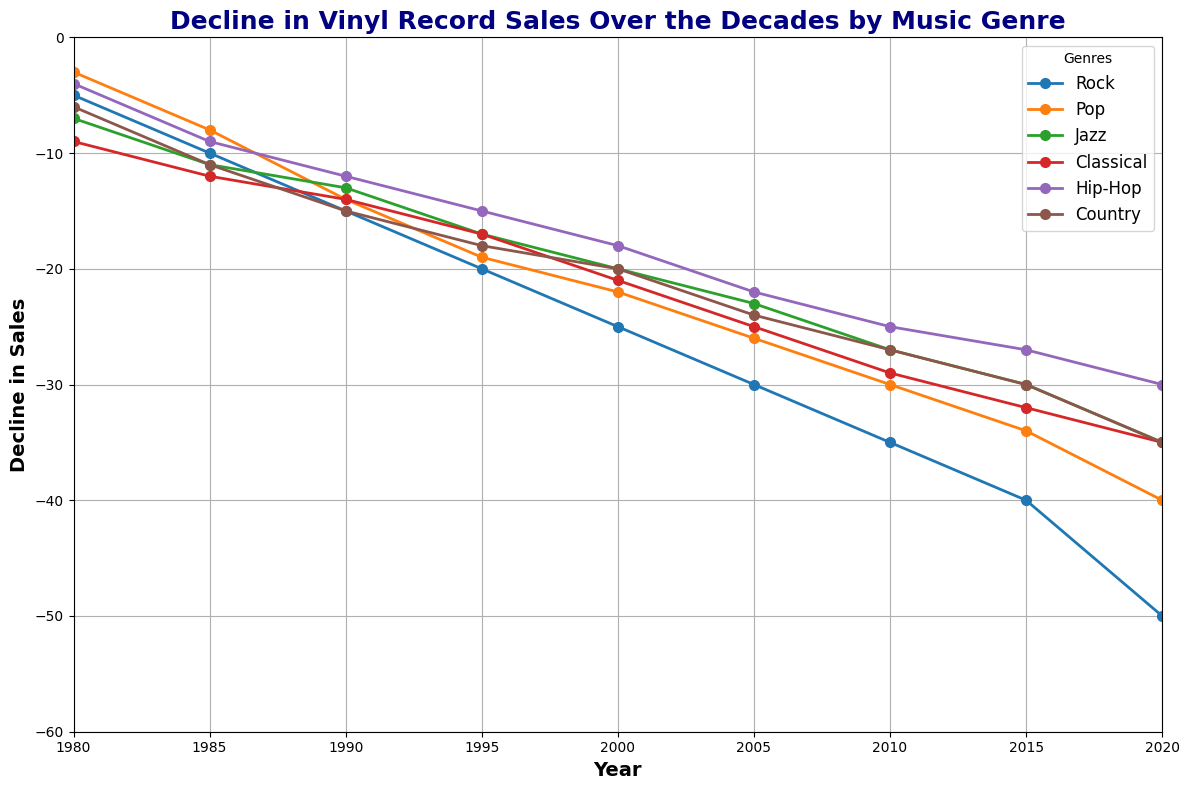What genre experienced the steepest decline in sales from 1985 to 1990? To determine the steepest decline, compute the difference between 1985 and 1990 for each genre. Rock: -15 - (-10) = -5, Pop: -14 - (-8) = -6, Jazz: -13 - (-11) = -2, Classical: -14 - (-12) = -2, Hip-Hop: -12 - (-9) = -3, Country: -15 - (-11) = -4. Pop has the steepest decline of -6.
Answer: Pop Which genre had the least decline in sales by 2020? By 2020, we check the values for each genre to see which is the least negative: Rock: -50, Pop: -40, Jazz: -35, Classical: -35, Hip-Hop: -30, Country: -35. Hip-Hop has the least decline at -30.
Answer: Hip-Hop What is the average decline in sales for Jazz from 1980 to 2020? Sum the declines for each year and divide by the number of years. (-7) + (-11) + (-13) + (-17) + (-20) + (-23) + (-27) + (-30) + (-35) = -183. There are 9 data points, so -183 / 9 ≈ -20.33.
Answer: -20.33 Between which two consecutive periods did Classical music see the greatest decline in sales? Calculate the difference for every consecutive period: (-12) - (-9) = -3, (-14) - (-12) = -2, (-17) - (-14) = -3, (-21) - (-17) = -4, (-25) - (-21) = -4, (-29) - (-25) = -4, (-32) - (-29) = -3, (-35) - (-32) = -3. The greatest decline of -4 happens during 2000-2005, 2005-2010, and 2010-2015.
Answer: 2000-2005, 2005-2010, and 2010-2015 Which genre showed the most consistent decline over the decades? A consistent decline would have roughly equal differences between each period. Calculate the differences for each genre: Rock’s differences are -5, -5, -5, -5, -5, -5, -5, -10; Pop: -5, -6, -5, -6, -4, -4, -4, -5; Jazz: -6, -2, -4, -3, -3, -4, -3, -5; Classical: -3, -2, -4, -4, -4, -3, -3; Hip-Hop: -5, -3, -3, -3, -3, -3, -3; Country: -5, -4, -3, -3, -4, -4, -5. Rock shows the most overall consistency outside of the last period.
Answer: Rock What was the decline in sales for Pop music in 2005, and how does it compare to the decline in sales for Hip-Hop in 2000? Pop in 2005 is -26 and Hip-Hop in 2000 is -18. The difference is -26 - (-18) = -8, thus Pop had a decline of 8 more than Hip-Hop in these respective years.
Answer: -8 Which genre had the largest decline between 1980 and 2020? Identifying each genre's decline, subtract the 1980 value from the 2020 value for each. Rock: -50 - (-5) = -45; Pop: -40 - (-3) = -37; Jazz: -35 - (-7) = -28; Classical: -35 - (-9) = -26; Hip-Hop: -30 - (-4) = -26; Country: -35 - (-6) = -29. Rock with -45 decline.
Answer: Rock 